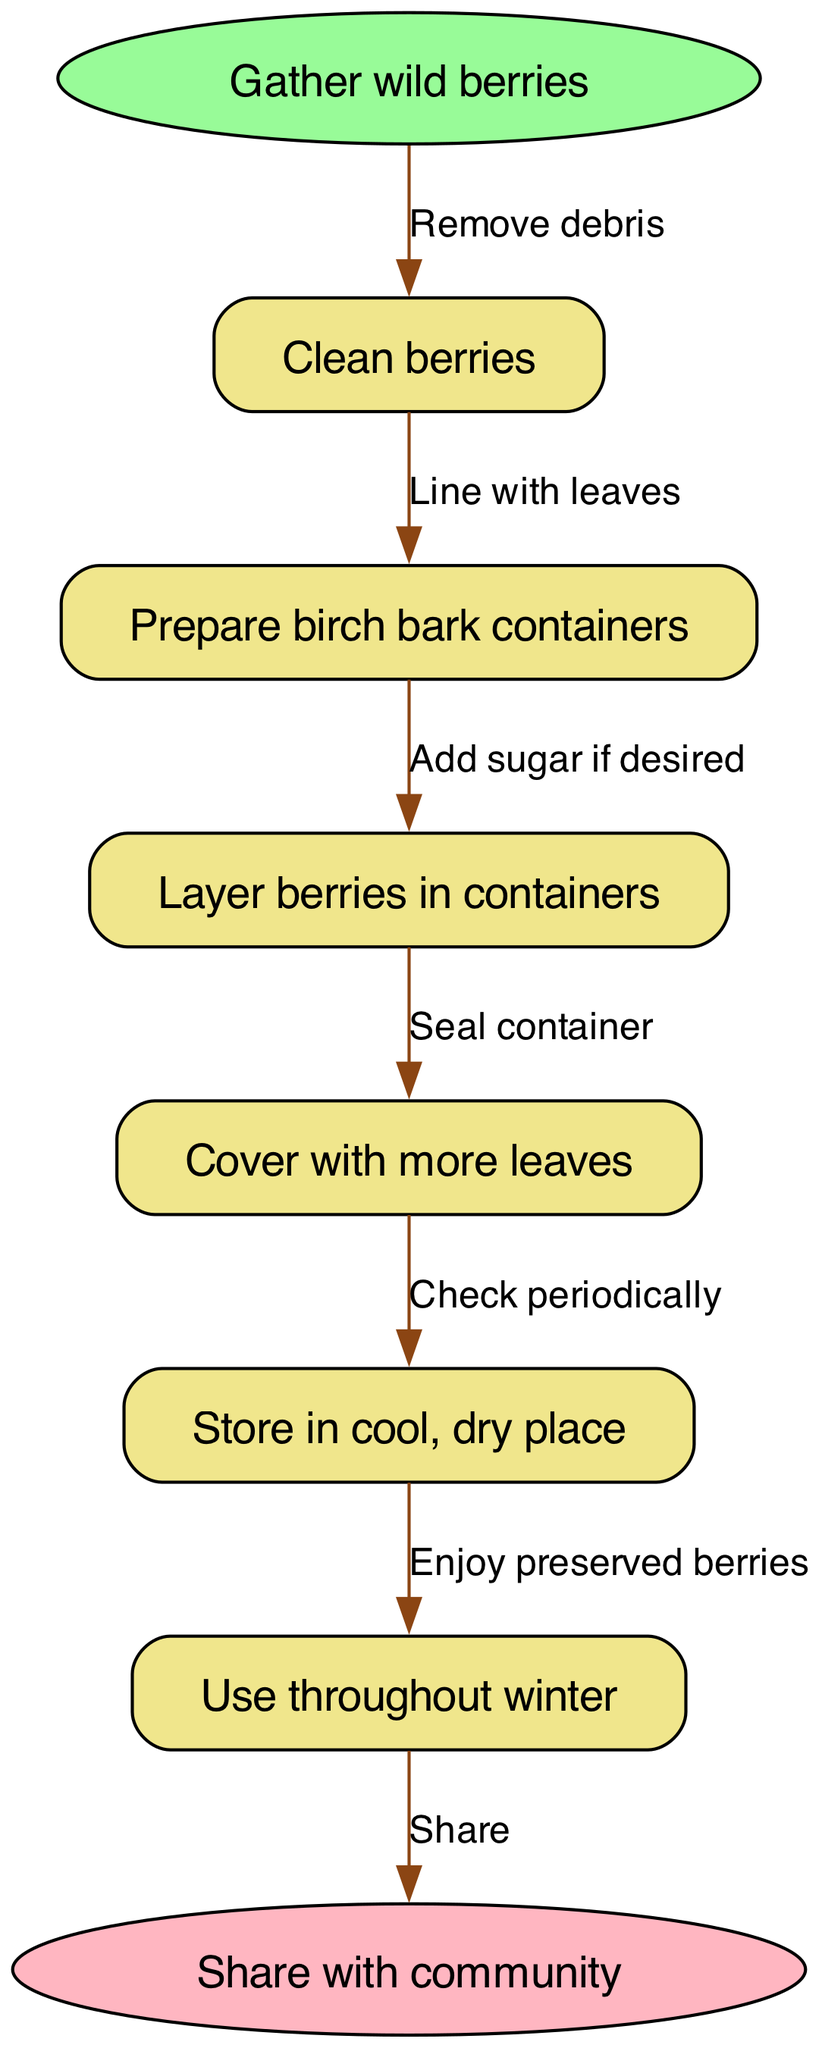What is the first step in the preservation process? The diagram indicates that the first step is "Gather wild berries." This can be seen as the start node in the flow chart.
Answer: Gather wild berries How many steps are there in total? By counting the steps listed in the diagram, we can see there are six distinct steps. This includes all the processes leading up to the final node.
Answer: 6 What do you do with the berries after storing them? The final node in the diagram shows that after the steps, you "Use throughout winter." This outlines the end use of the preserved berries.
Answer: Use throughout winter What action follows "Layer berries in containers"? The edge from the node "Layer berries in containers" leads to the next action which is "Cover with more leaves." This shows the sequential flow of steps.
Answer: Cover with more leaves What is the last action in the process? The last action in the flow chart leads to "Share with community," which is depicted at the end of the flow diagram. This shows the culmination of the berry preservation process.
Answer: Share with community What should be checked periodically during storage? The instruction following the node "Store in cool, dry place" indicates that one should "Check periodically." This suggests the need for maintenance during the storage period.
Answer: Check periodically Why is sugar mentioned in the layering step? The step "Layer berries in containers" includes an additional note that states "Add sugar if desired." This suggests that sugar can be optionally used to enhance the preservation.
Answer: Add sugar if desired 